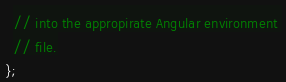<code> <loc_0><loc_0><loc_500><loc_500><_JavaScript_>  // into the appropirate Angular environment 
  // file.
};</code> 